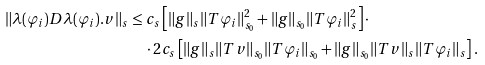Convert formula to latex. <formula><loc_0><loc_0><loc_500><loc_500>\| \lambda ( \varphi _ { i } ) D \lambda ( \varphi _ { i } ) . v \| _ { s } & \leq c _ { s } \left [ \| g \| _ { s } \| T \varphi _ { i } \| _ { s _ { 0 } } ^ { 2 } + \| g \| _ { s _ { 0 } } \| T \varphi _ { i } \| _ { s } ^ { 2 } \right ] \cdot \\ & \quad \cdot 2 c _ { s } \left [ \| g \| _ { s } \| T v \| _ { s _ { 0 } } \| T \varphi _ { i } \| _ { s _ { 0 } } + \| g \| _ { s _ { 0 } } \| T v \| _ { s } \| T \varphi _ { i } \| _ { s } \right ] .</formula> 